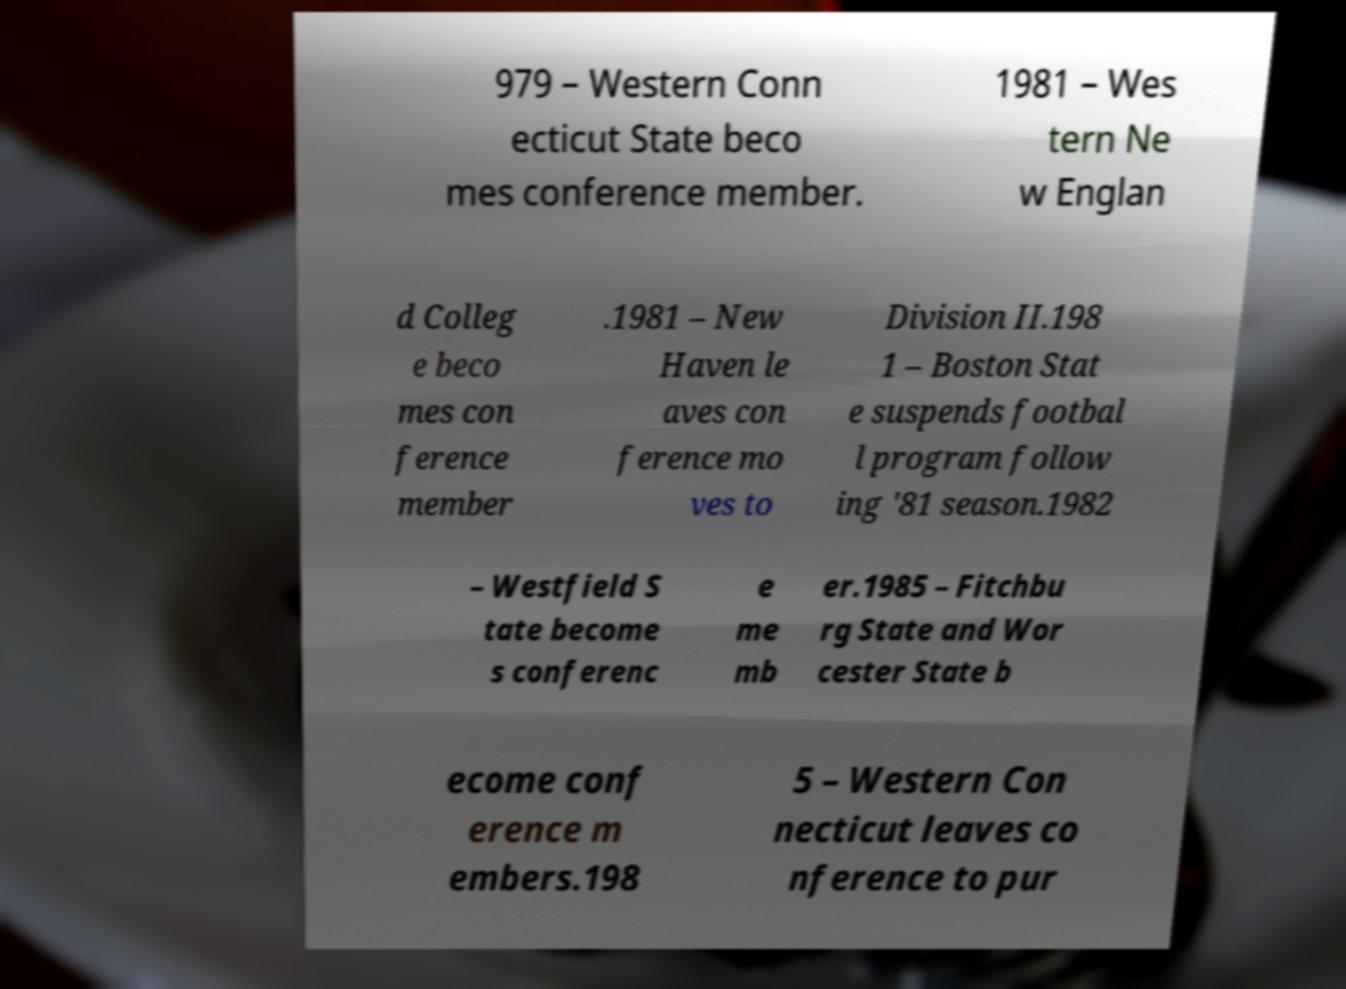Can you accurately transcribe the text from the provided image for me? 979 – Western Conn ecticut State beco mes conference member. 1981 – Wes tern Ne w Englan d Colleg e beco mes con ference member .1981 – New Haven le aves con ference mo ves to Division II.198 1 – Boston Stat e suspends footbal l program follow ing '81 season.1982 – Westfield S tate become s conferenc e me mb er.1985 – Fitchbu rg State and Wor cester State b ecome conf erence m embers.198 5 – Western Con necticut leaves co nference to pur 